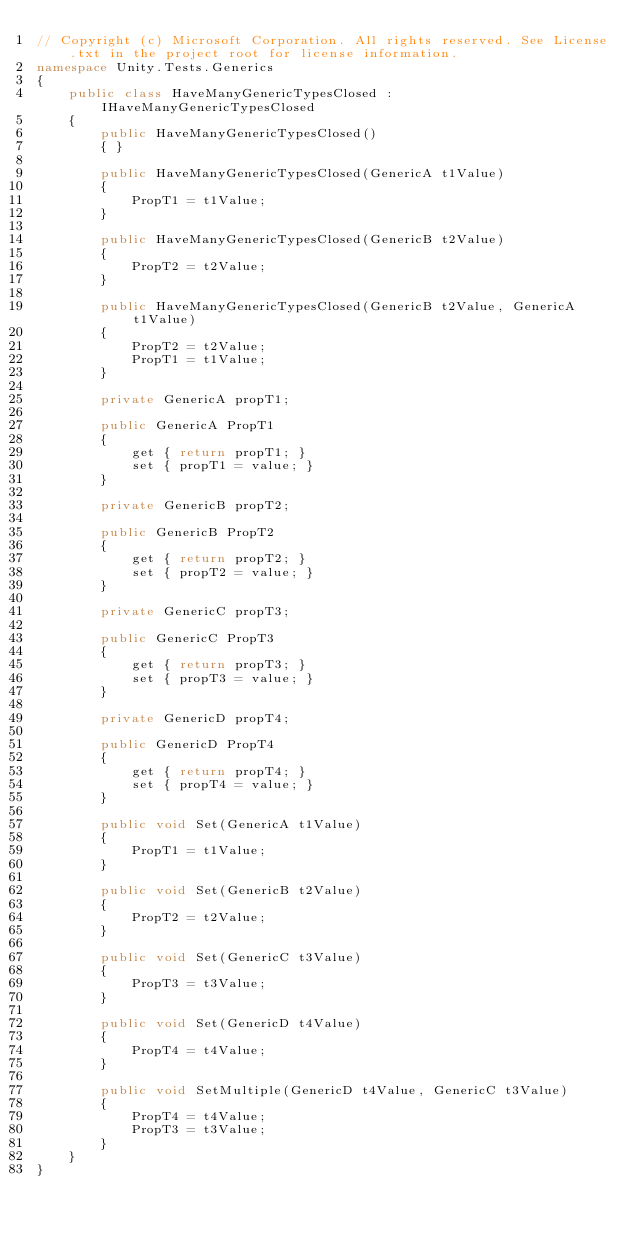Convert code to text. <code><loc_0><loc_0><loc_500><loc_500><_C#_>// Copyright (c) Microsoft Corporation. All rights reserved. See License.txt in the project root for license information.
namespace Unity.Tests.Generics
{
    public class HaveManyGenericTypesClosed : IHaveManyGenericTypesClosed
    {
        public HaveManyGenericTypesClosed()
        { }

        public HaveManyGenericTypesClosed(GenericA t1Value)
        {
            PropT1 = t1Value;
        }

        public HaveManyGenericTypesClosed(GenericB t2Value)
        {
            PropT2 = t2Value;
        }

        public HaveManyGenericTypesClosed(GenericB t2Value, GenericA t1Value)
        {
            PropT2 = t2Value;
            PropT1 = t1Value;
        }

        private GenericA propT1;

        public GenericA PropT1
        {
            get { return propT1; }
            set { propT1 = value; }
        }

        private GenericB propT2;

        public GenericB PropT2
        {
            get { return propT2; }
            set { propT2 = value; }
        }

        private GenericC propT3;

        public GenericC PropT3
        {
            get { return propT3; }
            set { propT3 = value; }
        }

        private GenericD propT4;

        public GenericD PropT4
        {
            get { return propT4; }
            set { propT4 = value; }
        }

        public void Set(GenericA t1Value)
        {
            PropT1 = t1Value;
        }

        public void Set(GenericB t2Value)
        {
            PropT2 = t2Value;
        }

        public void Set(GenericC t3Value)
        {
            PropT3 = t3Value;
        }

        public void Set(GenericD t4Value)
        {
            PropT4 = t4Value;
        }

        public void SetMultiple(GenericD t4Value, GenericC t3Value)
        {
            PropT4 = t4Value;
            PropT3 = t3Value;
        }
    }
}
</code> 